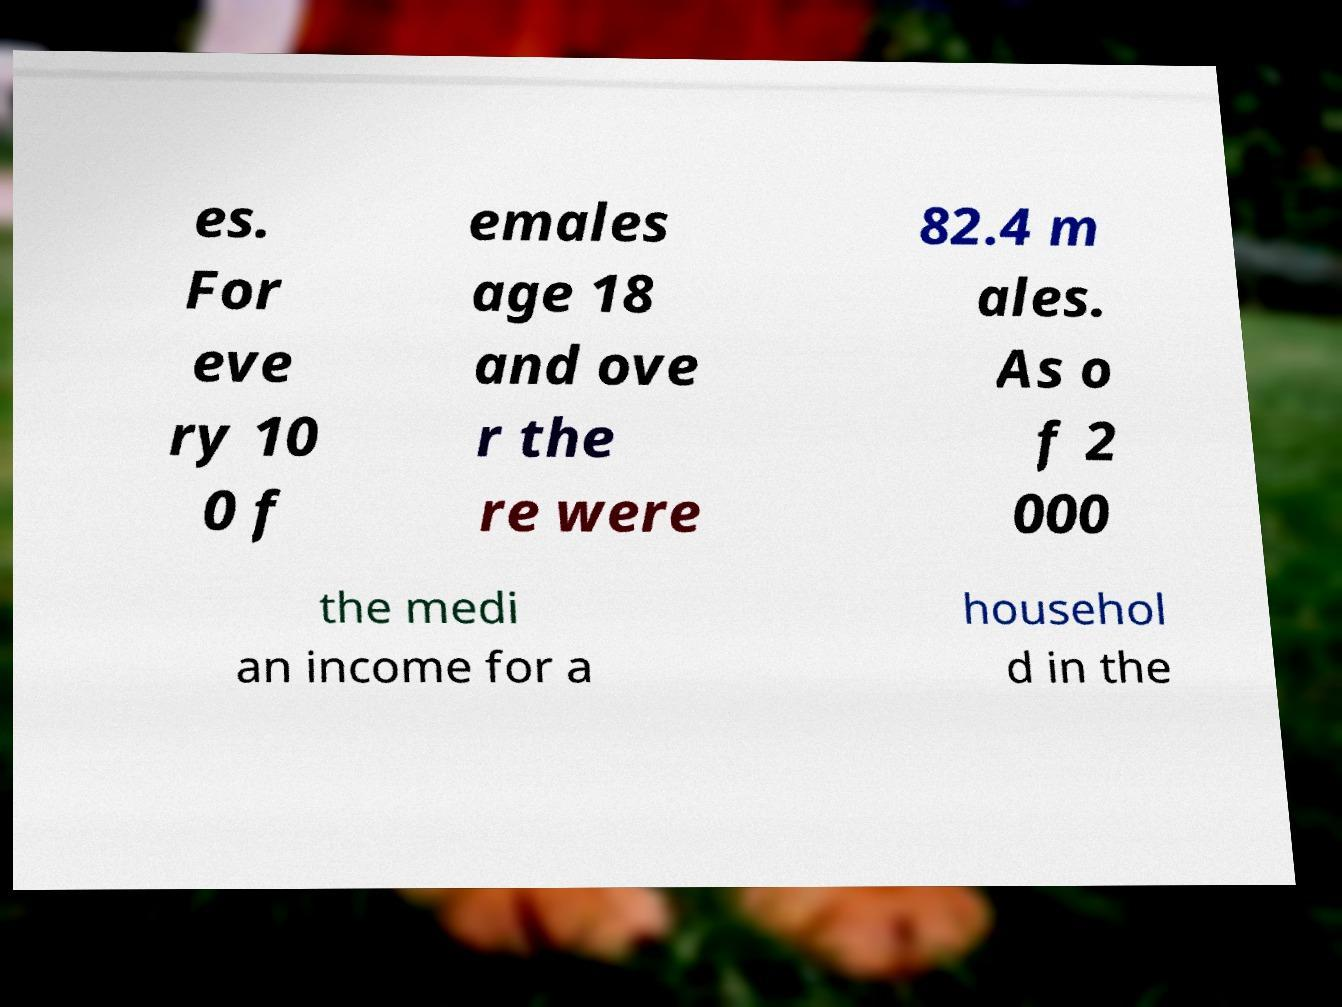There's text embedded in this image that I need extracted. Can you transcribe it verbatim? es. For eve ry 10 0 f emales age 18 and ove r the re were 82.4 m ales. As o f 2 000 the medi an income for a househol d in the 